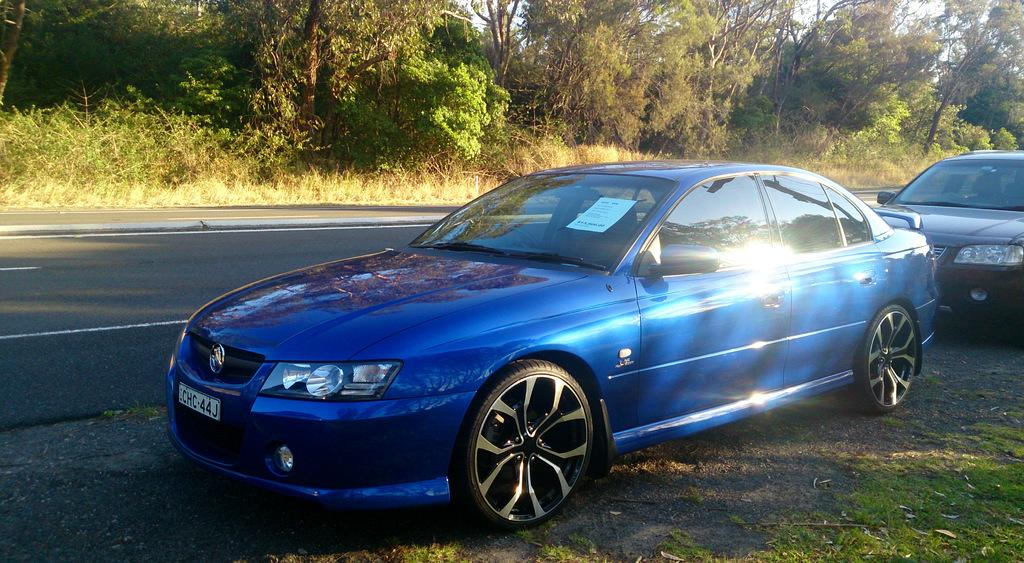What can be seen on the side of the road in the image? There are two cars parked on the side of the road. What is the main feature in the middle of the image? There is a road in the middle of the picture. What type of vegetation is visible in the background of the image? There are plants and trees in the background of the image. What type of can is visible on the road in the image? There is no can present on the road in the image. What direction are the trees pointing in the image? The trees do not have a specific direction they are pointing in the image; they are stationary and not moving. 